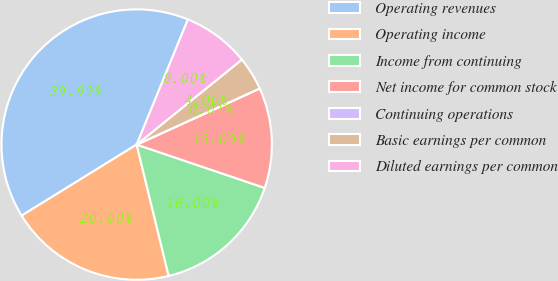Convert chart to OTSL. <chart><loc_0><loc_0><loc_500><loc_500><pie_chart><fcel>Operating revenues<fcel>Operating income<fcel>Income from continuing<fcel>Net income for common stock<fcel>Continuing operations<fcel>Basic earnings per common<fcel>Diluted earnings per common<nl><fcel>39.99%<fcel>20.0%<fcel>16.0%<fcel>12.0%<fcel>0.01%<fcel>4.0%<fcel>8.0%<nl></chart> 